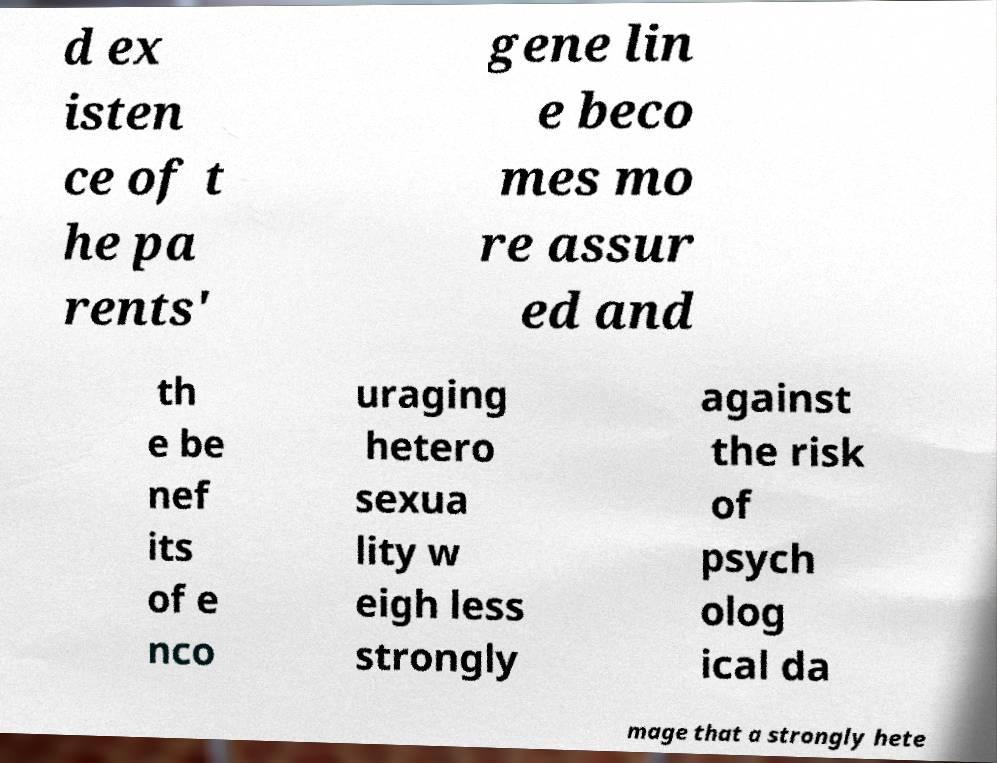Could you extract and type out the text from this image? d ex isten ce of t he pa rents' gene lin e beco mes mo re assur ed and th e be nef its of e nco uraging hetero sexua lity w eigh less strongly against the risk of psych olog ical da mage that a strongly hete 